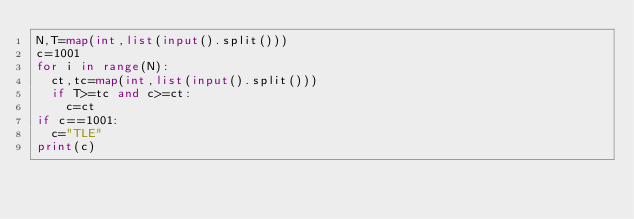Convert code to text. <code><loc_0><loc_0><loc_500><loc_500><_Python_>N,T=map(int,list(input().split()))
c=1001
for i in range(N):
  ct,tc=map(int,list(input().split()))
  if T>=tc and c>=ct:
    c=ct
if c==1001:
  c="TLE"
print(c)</code> 